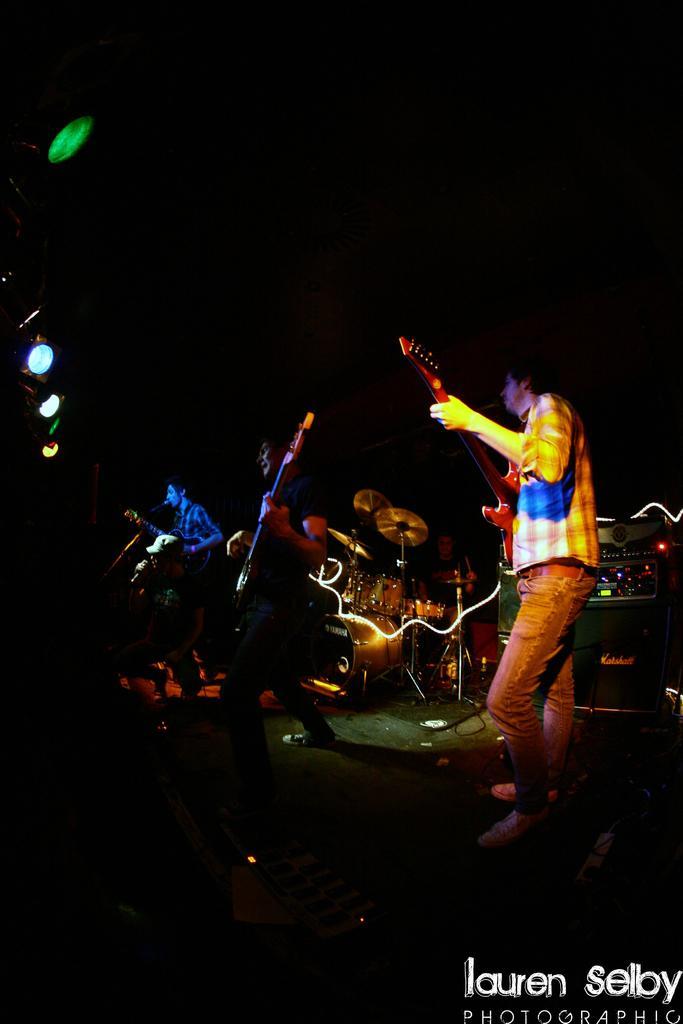Could you give a brief overview of what you see in this image? Here we can see a band playing guitars and drums and a person singing a song with a microphone in front of him and there are colorful lights present on the left 